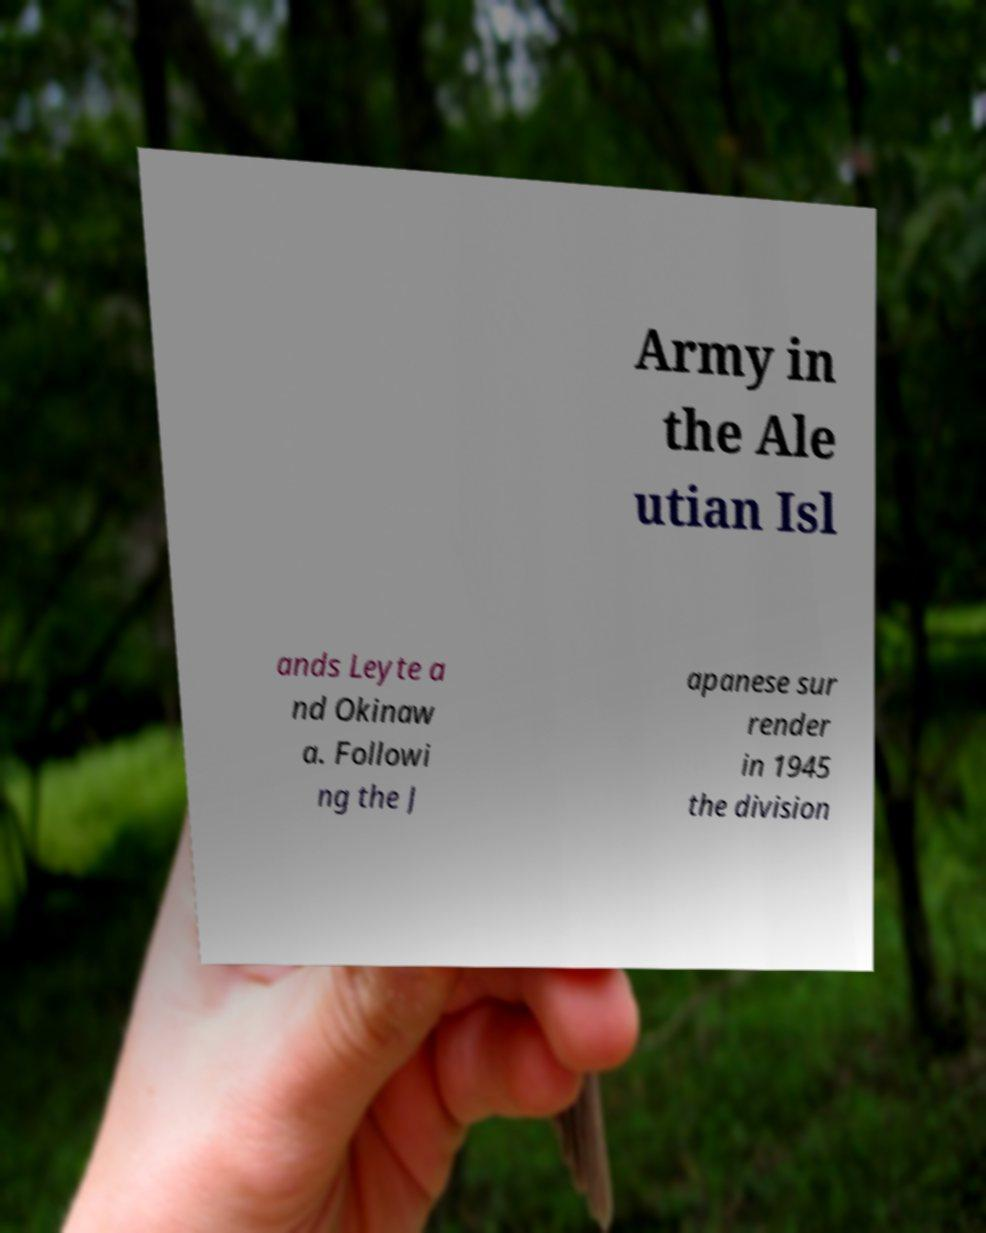There's text embedded in this image that I need extracted. Can you transcribe it verbatim? Army in the Ale utian Isl ands Leyte a nd Okinaw a. Followi ng the J apanese sur render in 1945 the division 